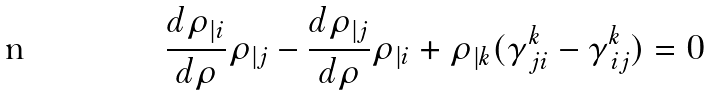<formula> <loc_0><loc_0><loc_500><loc_500>\frac { d \rho _ { | i } } { d \rho } \rho _ { | j } - \frac { d \rho _ { | j } } { d \rho } \rho _ { | i } + \rho _ { | k } ( \gamma ^ { k } _ { \, j i } - \gamma ^ { k } _ { \, i j } ) = 0</formula> 